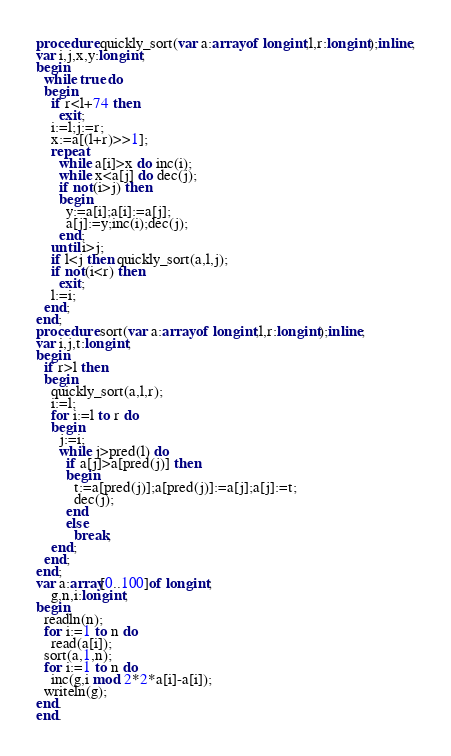Convert code to text. <code><loc_0><loc_0><loc_500><loc_500><_Pascal_>procedure quickly_sort(var a:array of longint;l,r:longint);inline;
var i,j,x,y:longint;
begin
  while true do
  begin
    if r<l+74 then
      exit;
    i:=l;j:=r;
    x:=a[(l+r)>>1];
    repeat
      while a[i]>x do inc(i);
      while x<a[j] do dec(j);
      if not(i>j) then
      begin
        y:=a[i];a[i]:=a[j];
        a[j]:=y;inc(i);dec(j);
      end;
    until i>j;
    if l<j then quickly_sort(a,l,j);
    if not(i<r) then
      exit;
    l:=i;
  end;
end;
procedure sort(var a:array of longint;l,r:longint);inline;
var i,j,t:longint;
begin
  if r>l then
  begin
    quickly_sort(a,l,r);
    i:=l;
    for i:=l to r do
    begin
      j:=i; 
      while j>pred(l) do
        if a[j]>a[pred(j)] then
        begin
          t:=a[pred(j)];a[pred(j)]:=a[j];a[j]:=t;
          dec(j);
        end
        else
          break;
    end;
  end;
end;
var a:array[0..100]of longint;
    g,n,i:longint;
begin
  readln(n);
  for i:=1 to n do
    read(a[i]);
  sort(a,1,n);
  for i:=1 to n do
    inc(g,i mod 2*2*a[i]-a[i]);
  writeln(g);
end.
end.</code> 